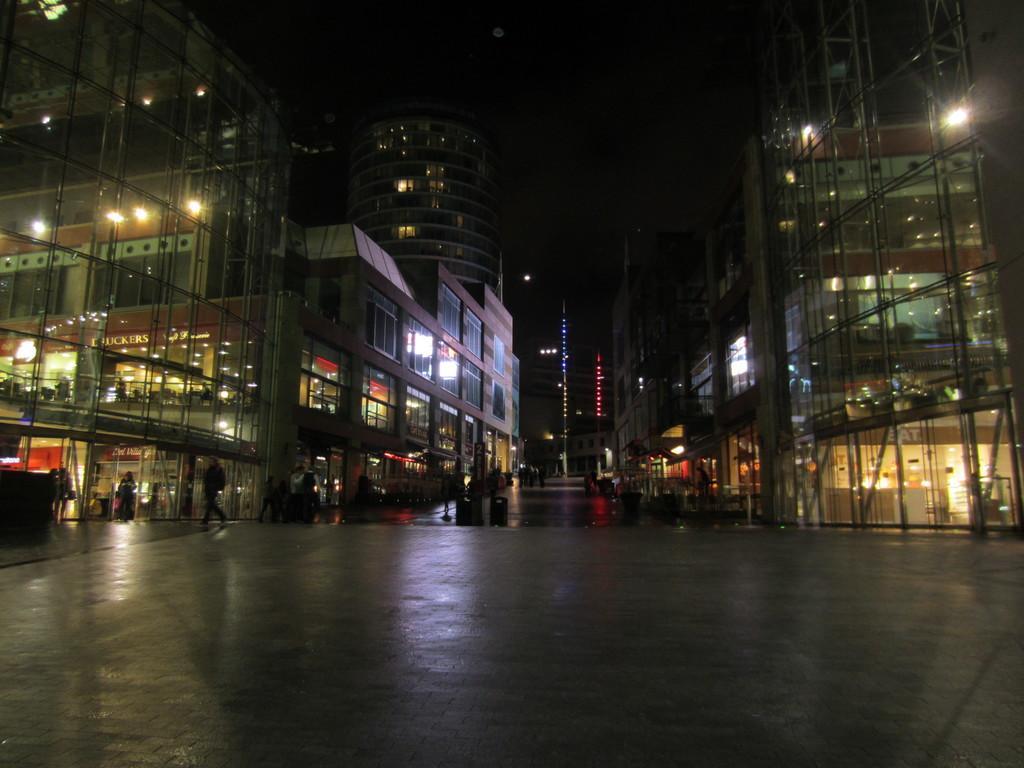Can you describe this image briefly? Here we can see buildings, lights, glasses, and few persons. There is a road and there is a dark background. 